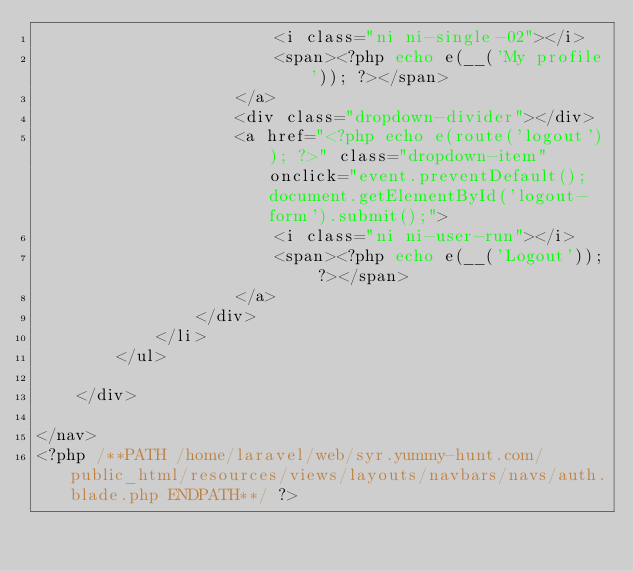Convert code to text. <code><loc_0><loc_0><loc_500><loc_500><_PHP_>                        <i class="ni ni-single-02"></i>
                        <span><?php echo e(__('My profile')); ?></span>
                    </a>
                    <div class="dropdown-divider"></div>
                    <a href="<?php echo e(route('logout')); ?>" class="dropdown-item" onclick="event.preventDefault(); document.getElementById('logout-form').submit();">
                        <i class="ni ni-user-run"></i>
                        <span><?php echo e(__('Logout')); ?></span>
                    </a>
                </div>
            </li>
        </ul>

    </div>

</nav>
<?php /**PATH /home/laravel/web/syr.yummy-hunt.com/public_html/resources/views/layouts/navbars/navs/auth.blade.php ENDPATH**/ ?></code> 